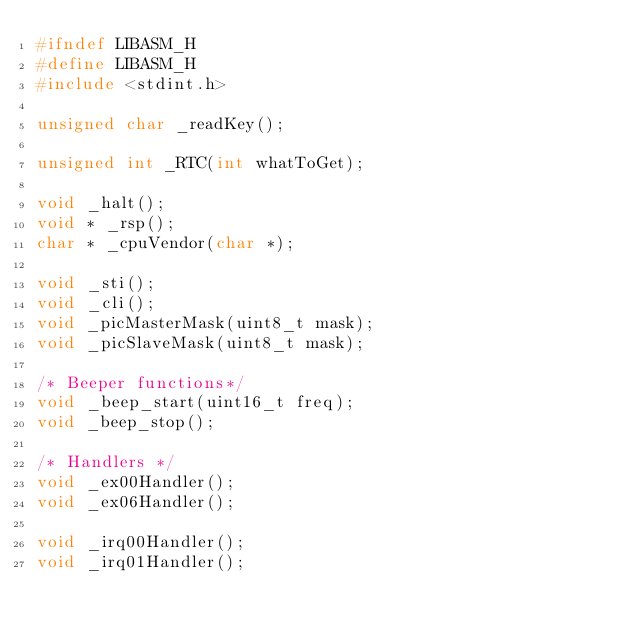<code> <loc_0><loc_0><loc_500><loc_500><_C_>#ifndef LIBASM_H
#define LIBASM_H
#include <stdint.h>

unsigned char _readKey();

unsigned int _RTC(int whatToGet);

void _halt();
void * _rsp();
char * _cpuVendor(char *);

void _sti();
void _cli();
void _picMasterMask(uint8_t mask);
void _picSlaveMask(uint8_t mask);

/* Beeper functions*/
void _beep_start(uint16_t freq);
void _beep_stop();

/* Handlers */
void _ex00Handler();
void _ex06Handler();

void _irq00Handler();
void _irq01Handler();</code> 